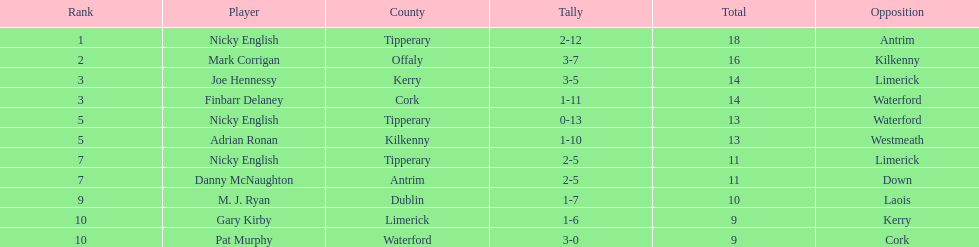Can you provide the count of people present in the list? 9. 